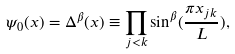<formula> <loc_0><loc_0><loc_500><loc_500>\psi _ { 0 } ( x ) = \Delta ^ { \beta } ( x ) \equiv \prod _ { j < k } \sin ^ { \beta } ( \frac { \pi x _ { j k } } { L } ) ,</formula> 